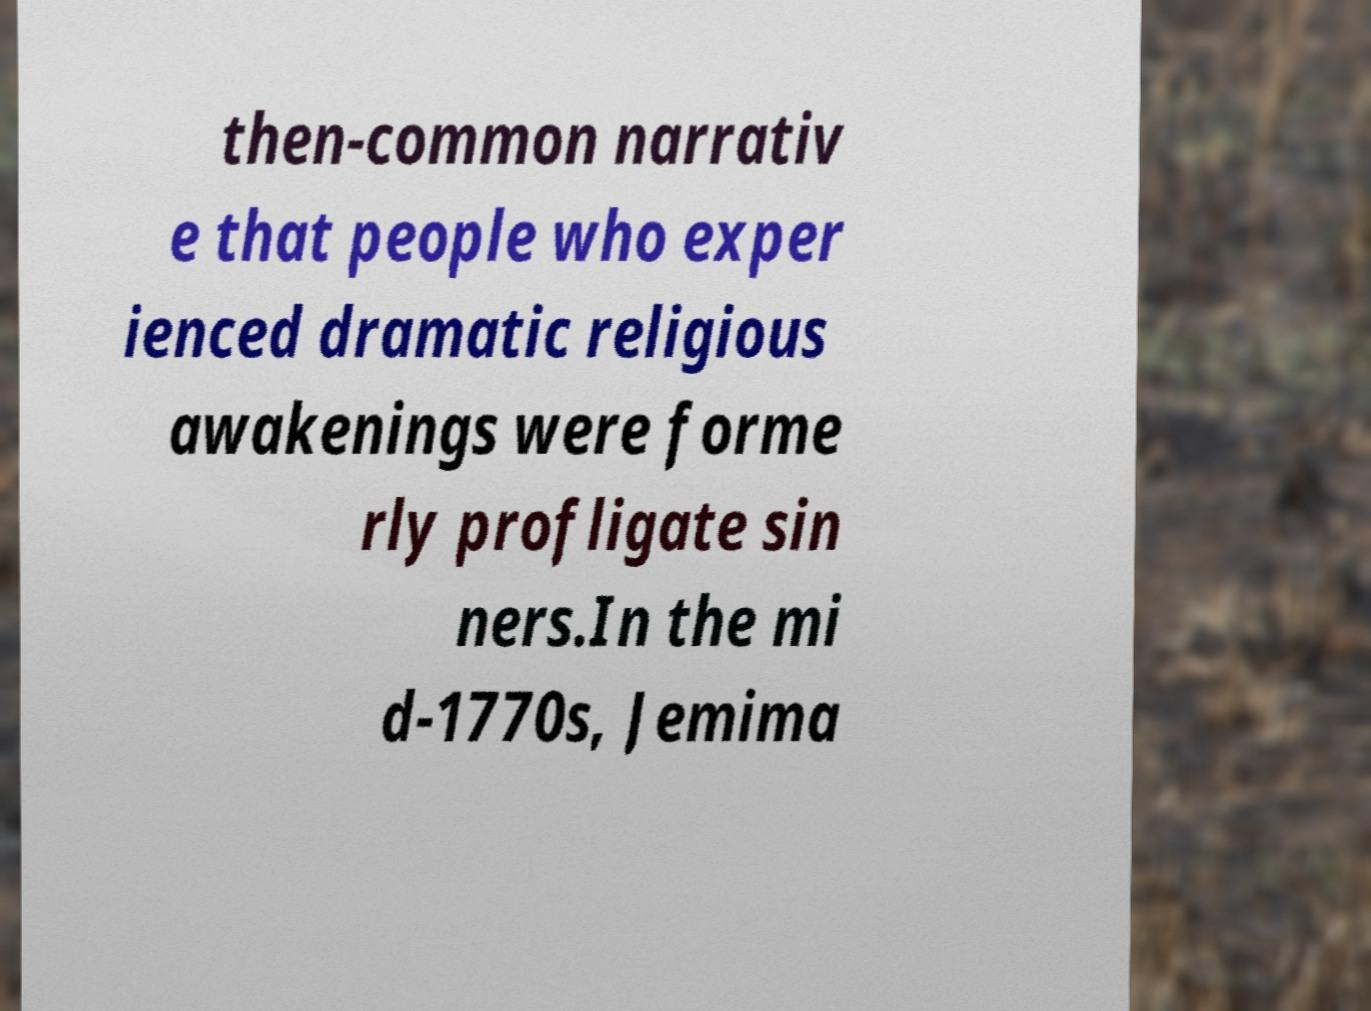Could you extract and type out the text from this image? then-common narrativ e that people who exper ienced dramatic religious awakenings were forme rly profligate sin ners.In the mi d-1770s, Jemima 